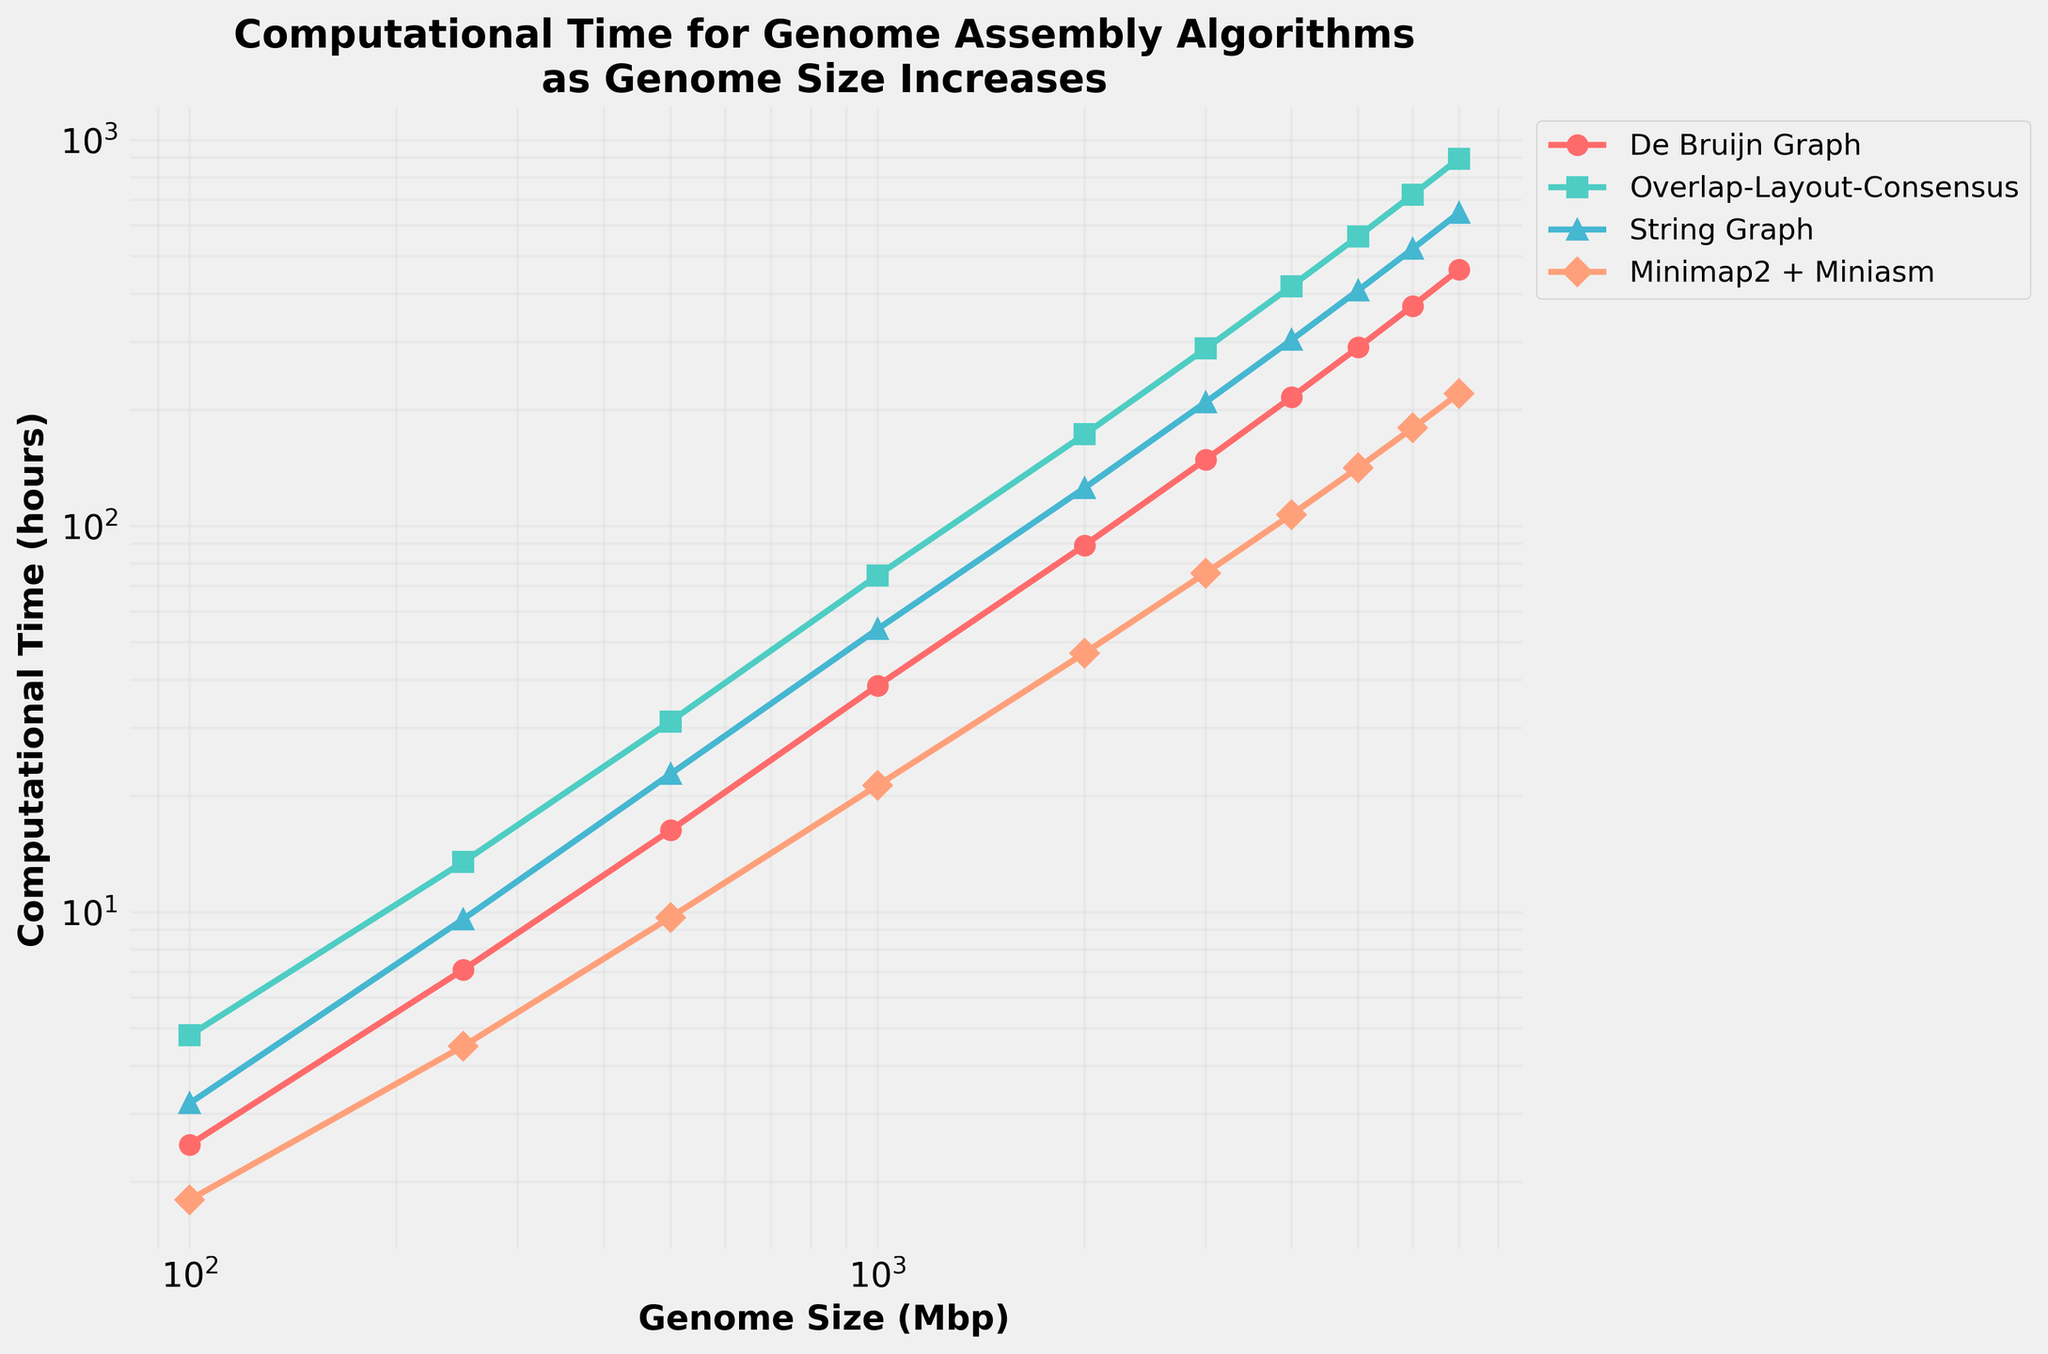What's the computational time for the De Bruijn Graph algorithm when the genome size is 1000 Mbp? Identify the line corresponding to "De Bruijn Graph" and locate the point at 1000 on the x-axis, then read the y-axis value
Answer: 38.6 hours Which algorithm shows the least computational time for a genome size of 2000 Mbp? Compare the y-axis values of each algorithm at the point where the x-axis value is 2000. "Minimap2 + Miniasm" has the smallest y-axis value
Answer: Minimap2 + Miniasm At what genome size does the Overlap-Layout-Consensus algorithm first exceed 100 hours of computational time? Locate the point where the Overlap-Layout-Consensus line crosses the 100-hour mark on the y-axis and note the corresponding x-axis value
Answer: 1000 Mbp How many times faster is Minimap2 + Miniasm compared to Overlap-Layout-Consensus for a genome size of 6000 Mbp? Identify the computational times for both algorithms at 6000 Mbp (179.5 hours for Minimap2 + Miniasm and 721.9 hours for Overlap-Layout-Consensus), then divide the Overlap-Layout-Consensus time by the Minimap2 + Miniasm time
Answer: 4.02 times What's the average computational time of the String Graph algorithm for genome sizes of 1000, 2000, and 3000 Mbp? Add the computational times for String Graph at 1000, 2000, and 3000 Mbp (54.1 + 125.6 + 209.4), then divide by the number of data points
Answer: 129.7 hours Which algorithm demonstrates the steepest increase in computational time as the genome size goes from 1000 to 2000 Mbp? Calculate the difference in computational times between 2000 and 1000 Mbp for all algorithms and compare the differences: De Bruijn Graph (89.2 - 38.6 = 50.6), Overlap-Layout-Consensus (172.8 - 74.5 = 98.3), String Graph (125.6 - 54.1 = 71.5), Minimap2 + Miniasm (46.9 - 21.3 = 25.6)
Answer: Overlap-Layout-Consensus Which color represents the String Graph algorithm in the plot? Match the legend label "String Graph" to its corresponding line color in the plot
Answer: Blue How many hours more does the Overlap-Layout-Consensus algorithm take than the De Bruijn Graph algorithm at 5000 Mbp? Find the computational times for both algorithms at 5000 Mbp (563.1 hours for Overlap-Layout-Consensus and 290.4 hours for De Bruijn Graph), then subtract the De Bruijn Graph time from the Overlap-Layout-Consensus time
Answer: 272.7 hours 